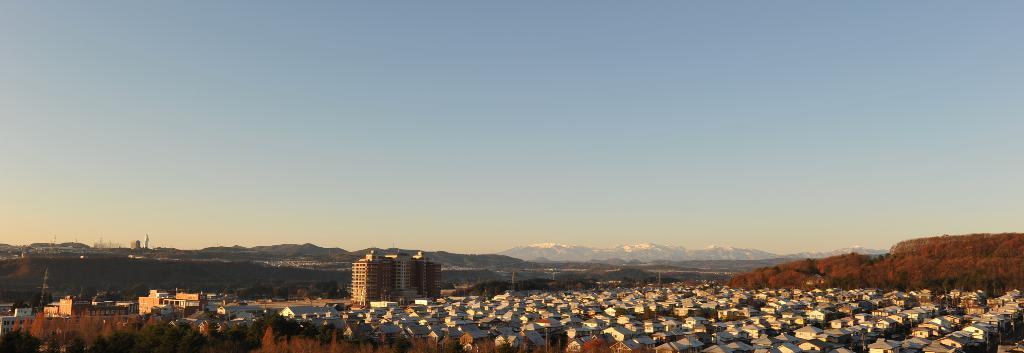What type of structures can be seen in the image? There are houses and buildings in the image. What natural elements are present in the image? There are trees in the image. What can be seen in the distance in the image? In the background of the image, there are hills. What is the total amount of debt owed by the trees in the image? There is no information about debt in the image, and trees do not have the ability to owe debt. 